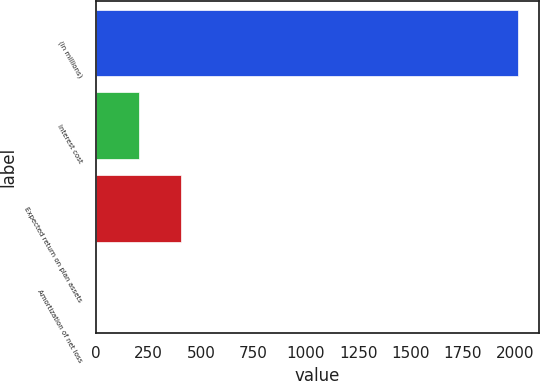<chart> <loc_0><loc_0><loc_500><loc_500><bar_chart><fcel>(in millions)<fcel>Interest cost<fcel>Expected return on plan assets<fcel>Amortization of net loss<nl><fcel>2013<fcel>202.2<fcel>403.4<fcel>1<nl></chart> 